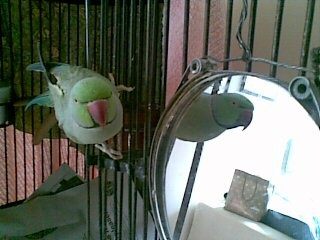Describe the objects in this image and their specific colors. I can see bird in black, gray, darkgray, and darkgreen tones, bird in black, gray, darkgreen, and teal tones, and handbag in black, darkgray, and gray tones in this image. 